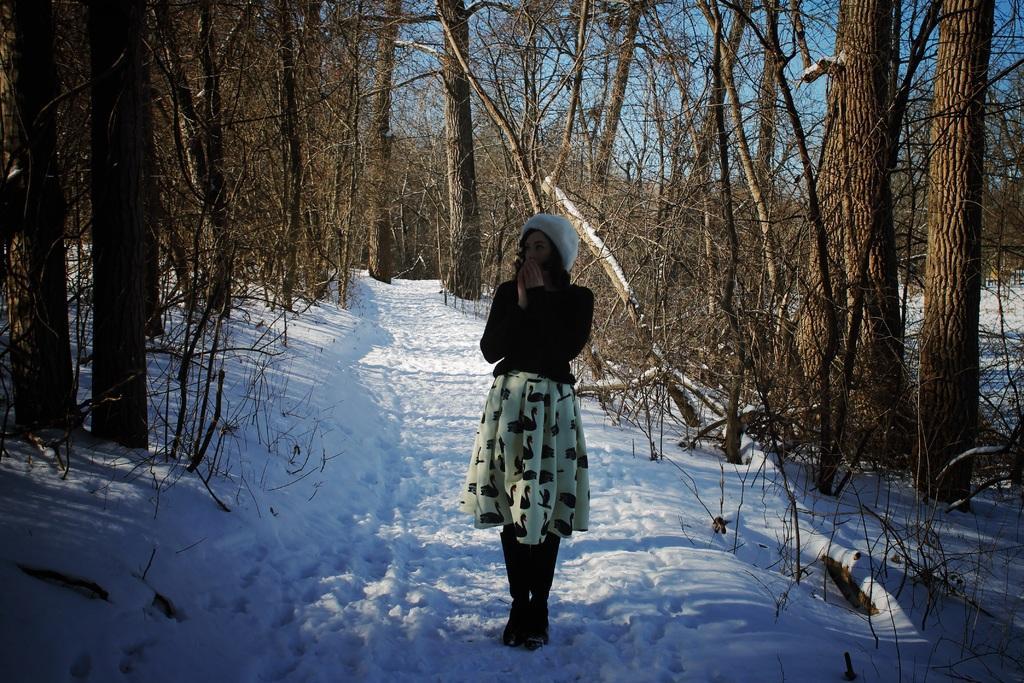Could you give a brief overview of what you see in this image? In this image we can see a woman wearing a dress is standing on the snow. In the background, we can see a group of trees and the sky. 